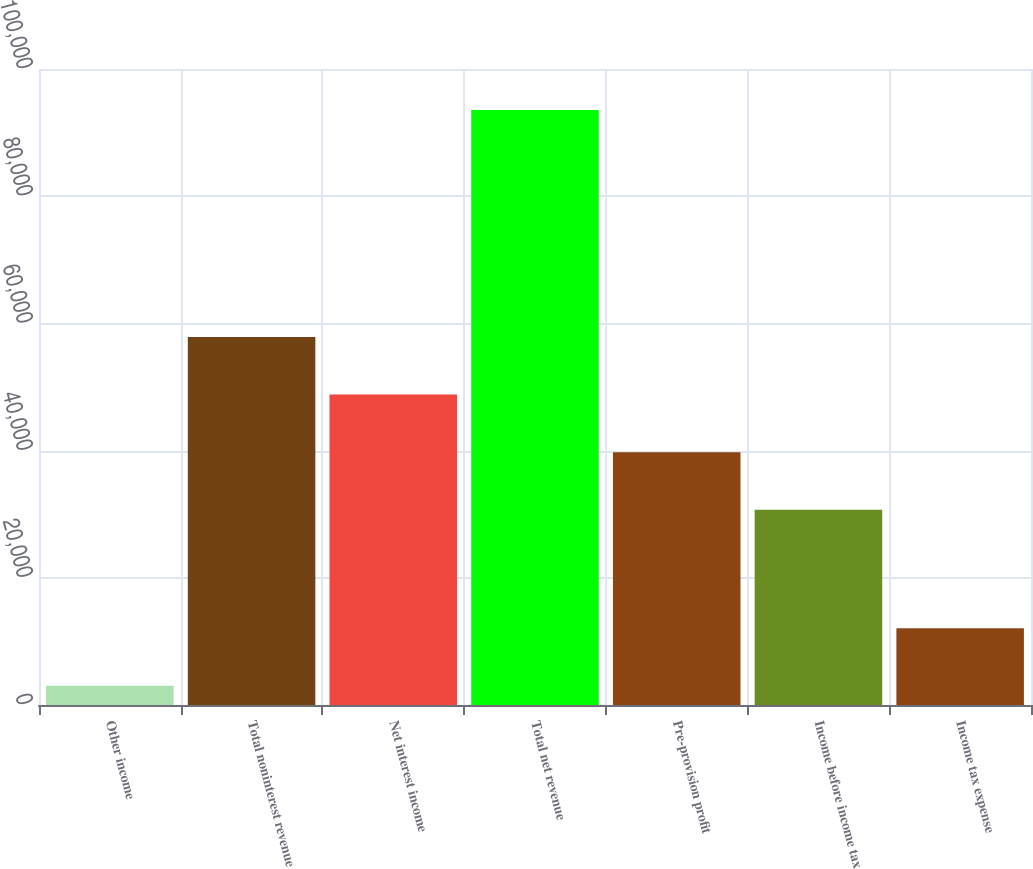Convert chart to OTSL. <chart><loc_0><loc_0><loc_500><loc_500><bar_chart><fcel>Other income<fcel>Total noninterest revenue<fcel>Net interest income<fcel>Total net revenue<fcel>Pre-provision profit<fcel>Income before income tax<fcel>Income tax expense<nl><fcel>3032<fcel>57855.3<fcel>48804.2<fcel>93543<fcel>39753.1<fcel>30702<fcel>12083.1<nl></chart> 